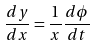<formula> <loc_0><loc_0><loc_500><loc_500>\frac { d y } { d x } = \frac { 1 } { x } \frac { d \phi } { d t }</formula> 